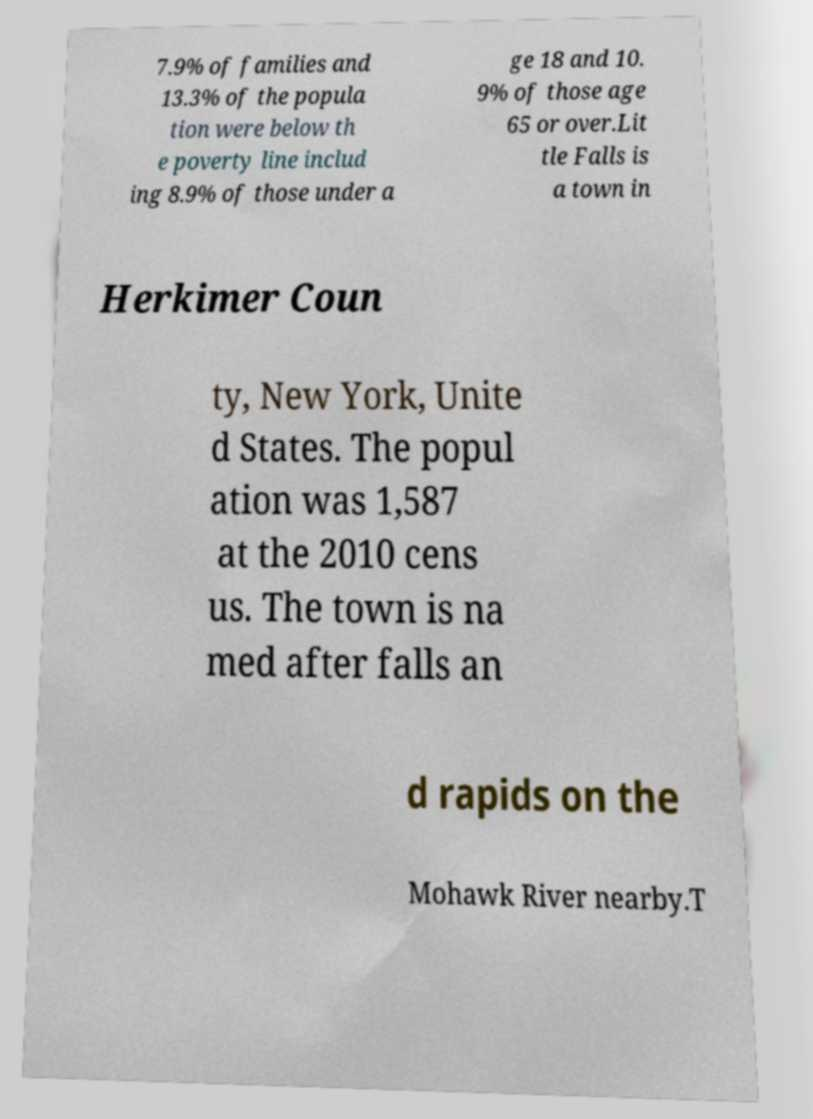Can you read and provide the text displayed in the image?This photo seems to have some interesting text. Can you extract and type it out for me? 7.9% of families and 13.3% of the popula tion were below th e poverty line includ ing 8.9% of those under a ge 18 and 10. 9% of those age 65 or over.Lit tle Falls is a town in Herkimer Coun ty, New York, Unite d States. The popul ation was 1,587 at the 2010 cens us. The town is na med after falls an d rapids on the Mohawk River nearby.T 